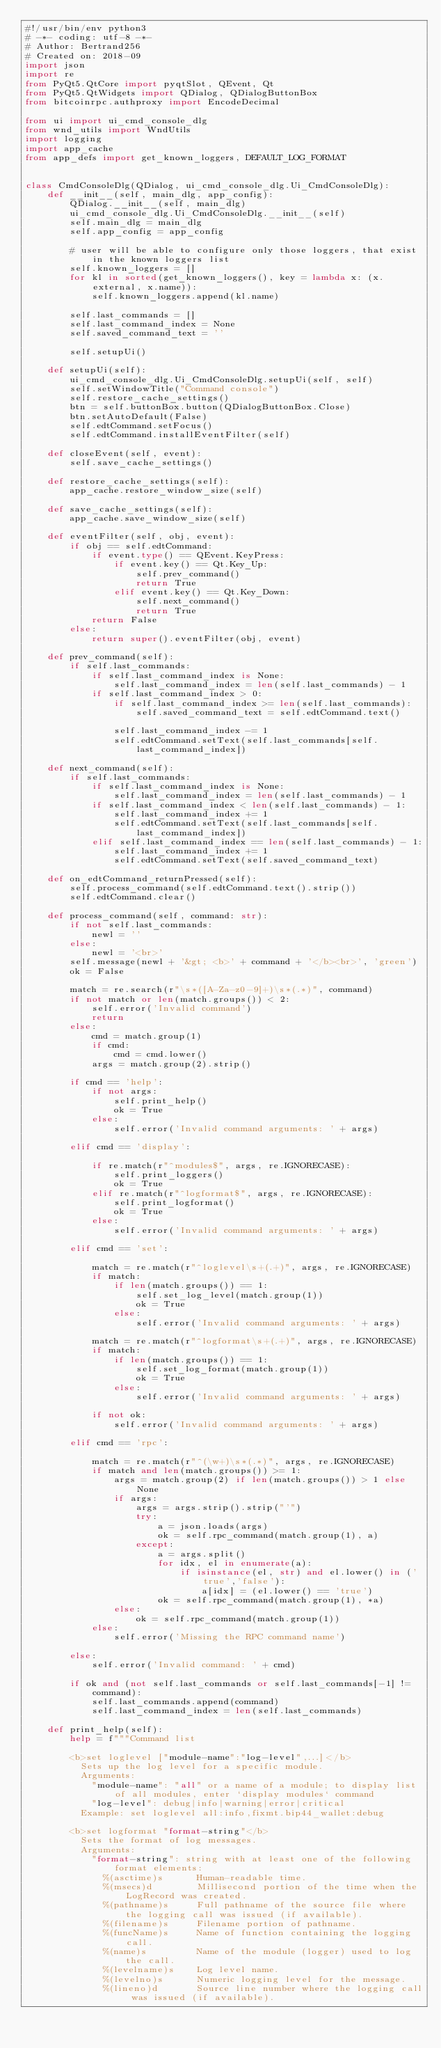Convert code to text. <code><loc_0><loc_0><loc_500><loc_500><_Python_>#!/usr/bin/env python3
# -*- coding: utf-8 -*-
# Author: Bertrand256
# Created on: 2018-09
import json
import re
from PyQt5.QtCore import pyqtSlot, QEvent, Qt
from PyQt5.QtWidgets import QDialog, QDialogButtonBox
from bitcoinrpc.authproxy import EncodeDecimal

from ui import ui_cmd_console_dlg
from wnd_utils import WndUtils
import logging
import app_cache
from app_defs import get_known_loggers, DEFAULT_LOG_FORMAT


class CmdConsoleDlg(QDialog, ui_cmd_console_dlg.Ui_CmdConsoleDlg):
    def __init__(self, main_dlg, app_config):
        QDialog.__init__(self, main_dlg)
        ui_cmd_console_dlg.Ui_CmdConsoleDlg.__init__(self)
        self.main_dlg = main_dlg
        self.app_config = app_config

        # user will be able to configure only those loggers, that exist in the known loggers list
        self.known_loggers = []
        for kl in sorted(get_known_loggers(), key = lambda x: (x.external, x.name)):
            self.known_loggers.append(kl.name)

        self.last_commands = []
        self.last_command_index = None
        self.saved_command_text = ''

        self.setupUi()

    def setupUi(self):
        ui_cmd_console_dlg.Ui_CmdConsoleDlg.setupUi(self, self)
        self.setWindowTitle("Command console")
        self.restore_cache_settings()
        btn = self.buttonBox.button(QDialogButtonBox.Close)
        btn.setAutoDefault(False)
        self.edtCommand.setFocus()
        self.edtCommand.installEventFilter(self)

    def closeEvent(self, event):
        self.save_cache_settings()

    def restore_cache_settings(self):
        app_cache.restore_window_size(self)

    def save_cache_settings(self):
        app_cache.save_window_size(self)

    def eventFilter(self, obj, event):
        if obj == self.edtCommand:
            if event.type() == QEvent.KeyPress:
                if event.key() == Qt.Key_Up:
                    self.prev_command()
                    return True
                elif event.key() == Qt.Key_Down:
                    self.next_command()
                    return True
            return False
        else:
            return super().eventFilter(obj, event)

    def prev_command(self):
        if self.last_commands:
            if self.last_command_index is None:
                self.last_command_index = len(self.last_commands) - 1
            if self.last_command_index > 0:
                if self.last_command_index >= len(self.last_commands):
                    self.saved_command_text = self.edtCommand.text()

                self.last_command_index -= 1
                self.edtCommand.setText(self.last_commands[self.last_command_index])

    def next_command(self):
        if self.last_commands:
            if self.last_command_index is None:
                self.last_command_index = len(self.last_commands) - 1
            if self.last_command_index < len(self.last_commands) - 1:
                self.last_command_index += 1
                self.edtCommand.setText(self.last_commands[self.last_command_index])
            elif self.last_command_index == len(self.last_commands) - 1:
                self.last_command_index += 1
                self.edtCommand.setText(self.saved_command_text)

    def on_edtCommand_returnPressed(self):
        self.process_command(self.edtCommand.text().strip())
        self.edtCommand.clear()

    def process_command(self, command: str):
        if not self.last_commands:
            newl = ''
        else:
            newl = '<br>'
        self.message(newl + '&gt; <b>' + command + '</b><br>', 'green')
        ok = False

        match = re.search(r"\s*([A-Za-z0-9]+)\s*(.*)", command)
        if not match or len(match.groups()) < 2:
            self.error('Invalid command')
            return
        else:
            cmd = match.group(1)
            if cmd:
                cmd = cmd.lower()
            args = match.group(2).strip()

        if cmd == 'help':
            if not args:
                self.print_help()
                ok = True
            else:
                self.error('Invalid command arguments: ' + args)

        elif cmd == 'display':

            if re.match(r"^modules$", args, re.IGNORECASE):
                self.print_loggers()
                ok = True
            elif re.match(r"^logformat$", args, re.IGNORECASE):
                self.print_logformat()
                ok = True
            else:
                self.error('Invalid command arguments: ' + args)

        elif cmd == 'set':

            match = re.match(r"^loglevel\s+(.+)", args, re.IGNORECASE)
            if match:
                if len(match.groups()) == 1:
                    self.set_log_level(match.group(1))
                    ok = True
                else:
                    self.error('Invalid command arguments: ' + args)

            match = re.match(r"^logformat\s+(.+)", args, re.IGNORECASE)
            if match:
                if len(match.groups()) == 1:
                    self.set_log_format(match.group(1))
                    ok = True
                else:
                    self.error('Invalid command arguments: ' + args)

            if not ok:
                self.error('Invalid command arguments: ' + args)

        elif cmd == 'rpc':

            match = re.match(r"^(\w+)\s*(.*)", args, re.IGNORECASE)
            if match and len(match.groups()) >= 1:
                args = match.group(2) if len(match.groups()) > 1 else None
                if args:
                    args = args.strip().strip("'")
                    try:
                        a = json.loads(args)
                        ok = self.rpc_command(match.group(1), a)
                    except:
                        a = args.split()
                        for idx, el in enumerate(a):
                            if isinstance(el, str) and el.lower() in ('true','false'):
                                a[idx] = (el.lower() == 'true')
                        ok = self.rpc_command(match.group(1), *a)
                else:
                    ok = self.rpc_command(match.group(1))
            else:
                self.error('Missing the RPC command name')

        else:
            self.error('Invalid command: ' + cmd)

        if ok and (not self.last_commands or self.last_commands[-1] != command):
            self.last_commands.append(command)
            self.last_command_index = len(self.last_commands)

    def print_help(self):
        help = f"""Command list
        
        <b>set loglevel ["module-name":"log-level",...]</b>
          Sets up the log level for a specific module.
          Arguments:
            "module-name": "all" or a name of a module; to display list of all modules, enter `display modules` command
            "log-level": debug|info|warning|error|critical
          Example: set loglevel all:info,fixmt.bip44_wallet:debug  
            
        <b>set logformat "format-string"</b>
          Sets the format of log messages.
          Arguments:
            "format-string": string with at least one of the following format elements:
              %(asctime)s      Human-readable time.
              %(msecs)d        Millisecond portion of the time when the LogRecord was created.
              %(pathname)s     Full pathname of the source file where the logging call was issued (if available).
              %(filename)s     Filename portion of pathname.
              %(funcName)s     Name of function containing the logging call.
              %(name)s         Name of the module (logger) used to log the call.
              %(levelname)s    Log level name.
              %(levelno)s      Numeric logging level for the message.
              %(lineno)d       Source line number where the logging call was issued (if available).</code> 